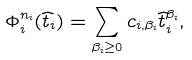<formula> <loc_0><loc_0><loc_500><loc_500>\Phi _ { i } ^ { n _ { i } } ( \widehat { t } _ { i } ) = \sum _ { \beta _ { i } \geq 0 } c _ { i , \beta _ { i } } \widehat { t } _ { i } ^ { \beta _ { i } } ,</formula> 